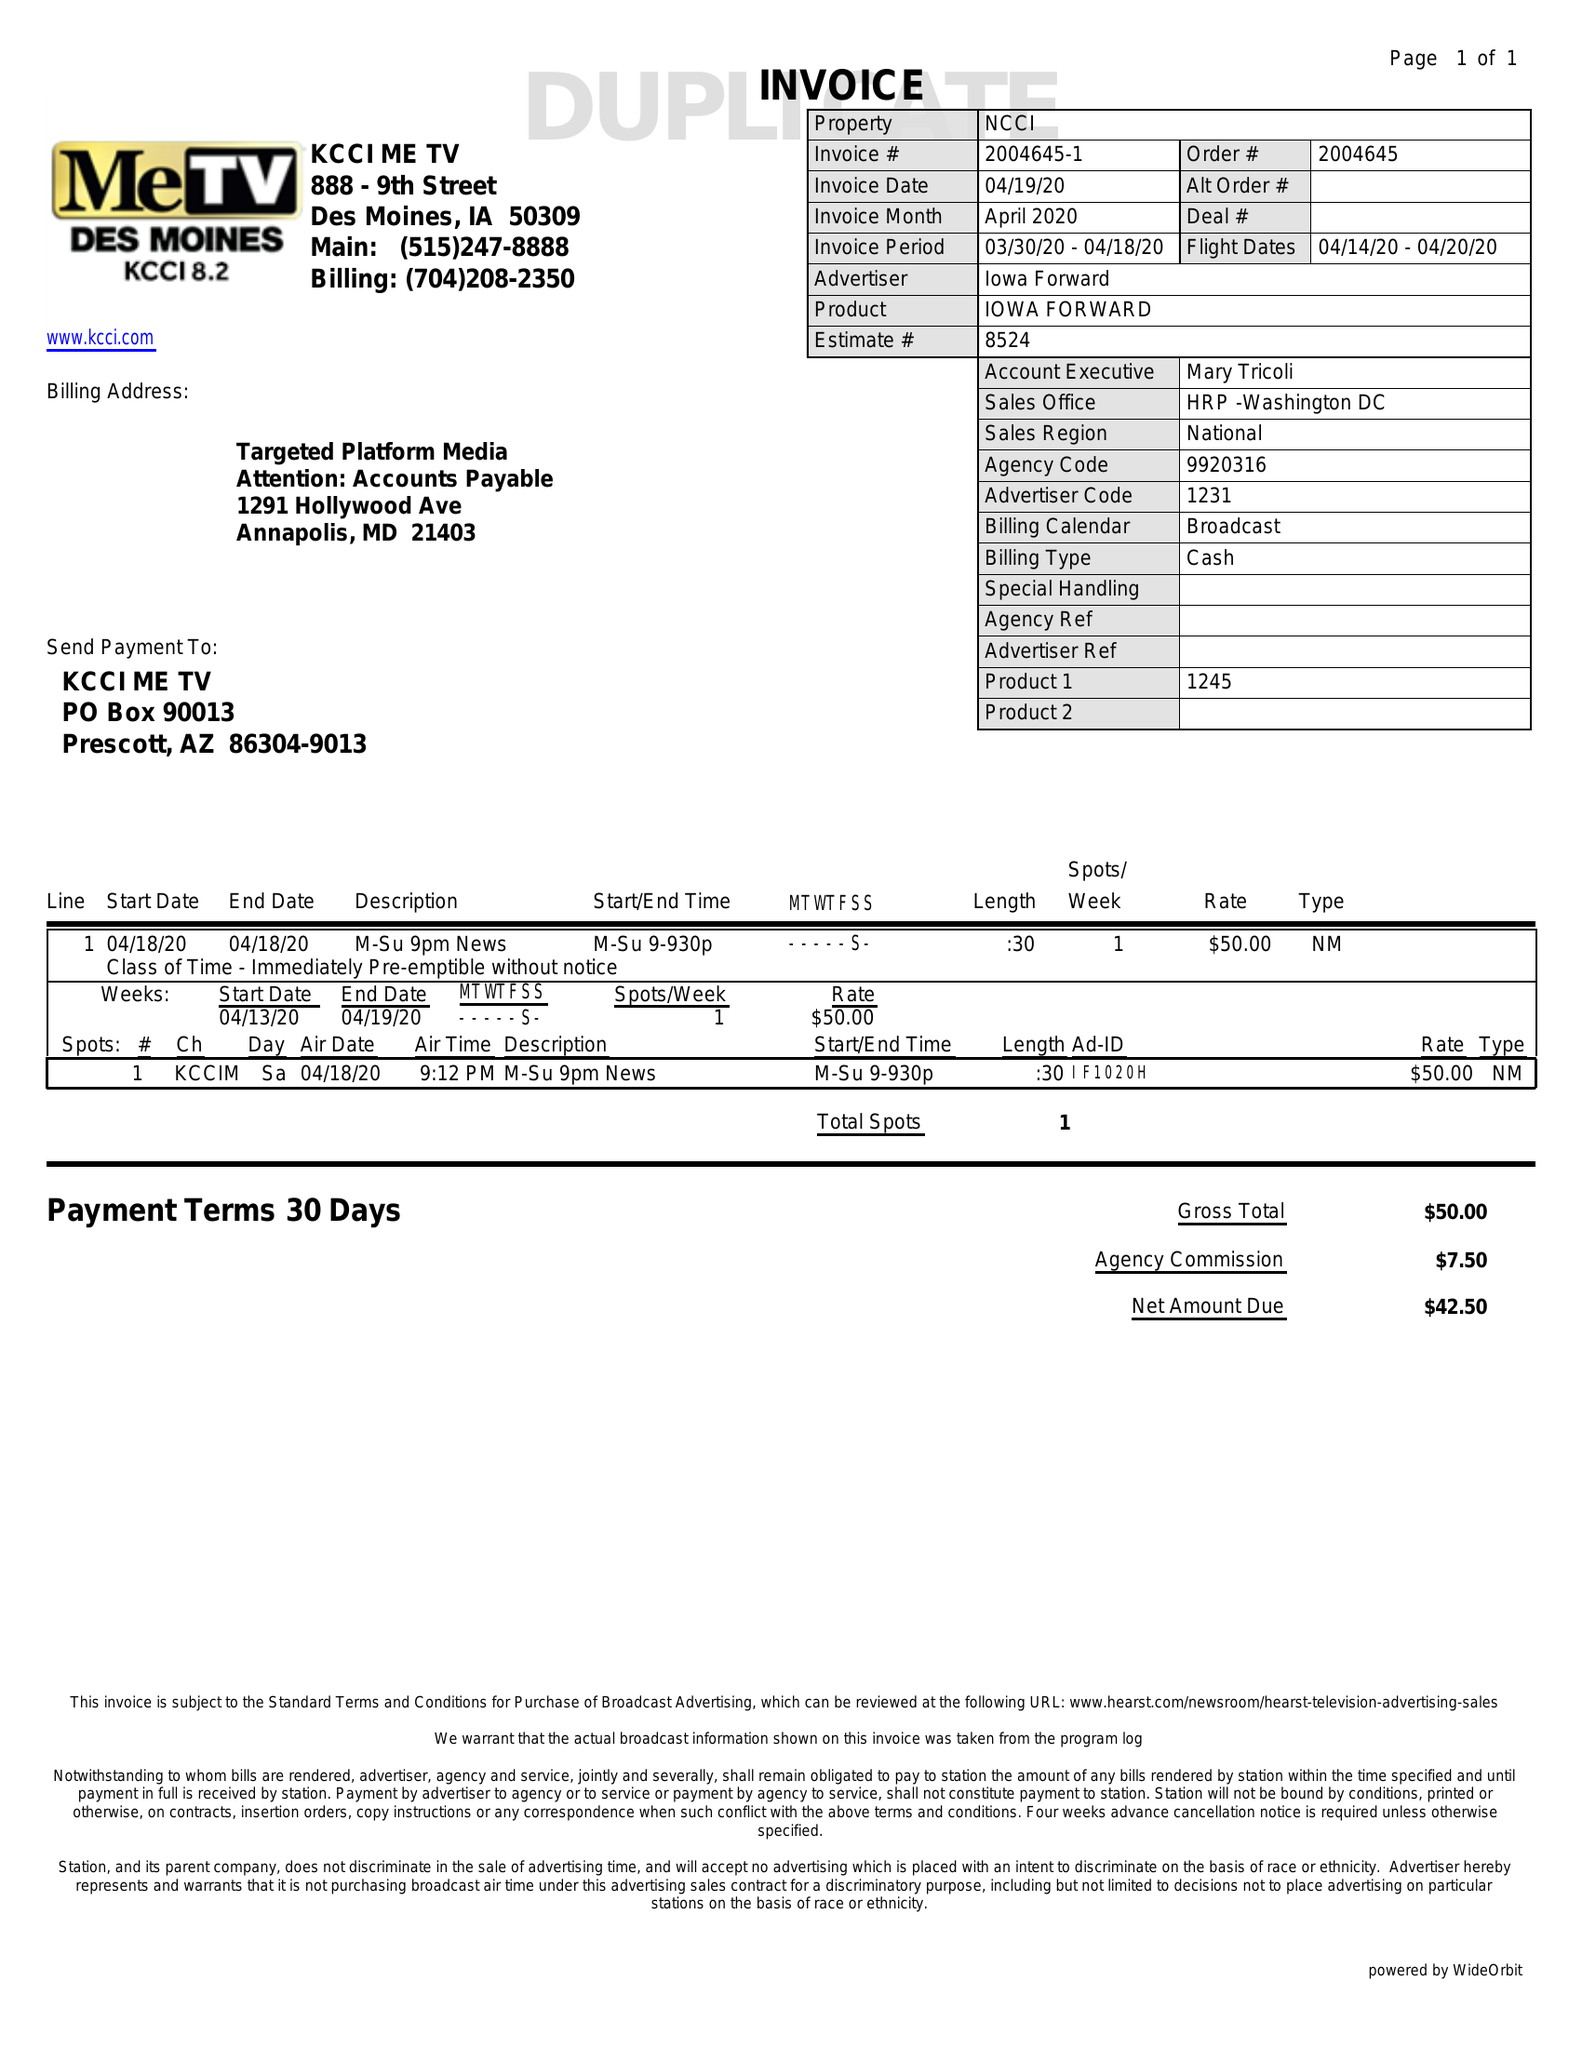What is the value for the gross_amount?
Answer the question using a single word or phrase. 50.00 